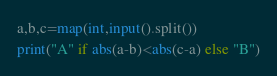<code> <loc_0><loc_0><loc_500><loc_500><_Python_>a,b,c=map(int,input().split())
print("A" if abs(a-b)<abs(c-a) else "B")</code> 